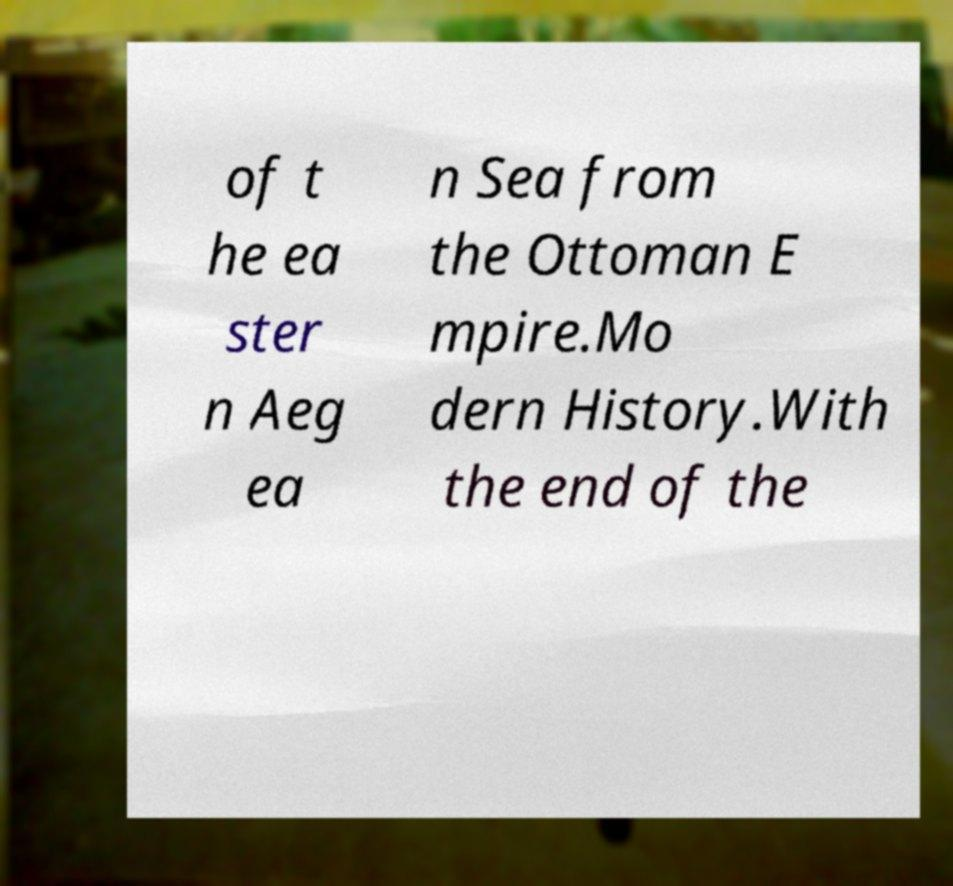There's text embedded in this image that I need extracted. Can you transcribe it verbatim? of t he ea ster n Aeg ea n Sea from the Ottoman E mpire.Mo dern History.With the end of the 